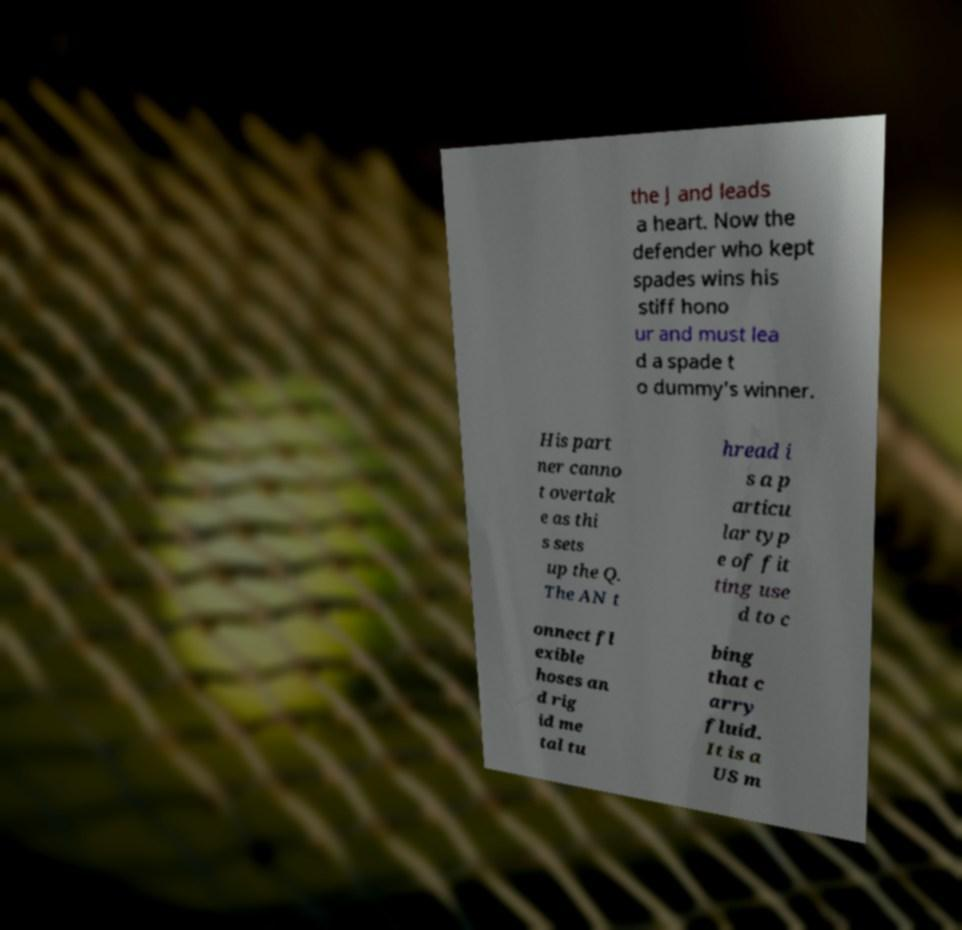Could you assist in decoding the text presented in this image and type it out clearly? the J and leads a heart. Now the defender who kept spades wins his stiff hono ur and must lea d a spade t o dummy's winner. His part ner canno t overtak e as thi s sets up the Q. The AN t hread i s a p articu lar typ e of fit ting use d to c onnect fl exible hoses an d rig id me tal tu bing that c arry fluid. It is a US m 